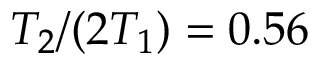Convert formula to latex. <formula><loc_0><loc_0><loc_500><loc_500>T _ { 2 } / ( 2 T _ { 1 } ) = 0 . 5 6</formula> 